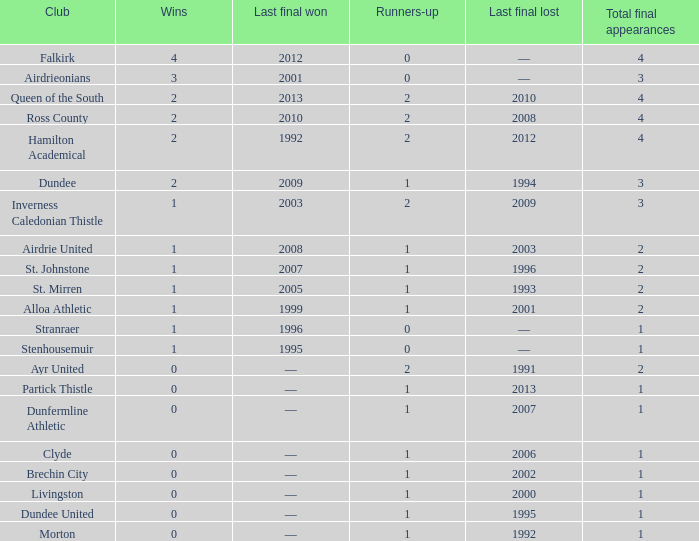How manywins for dunfermline athletic that has a total final appearances less than 2? 0.0. 